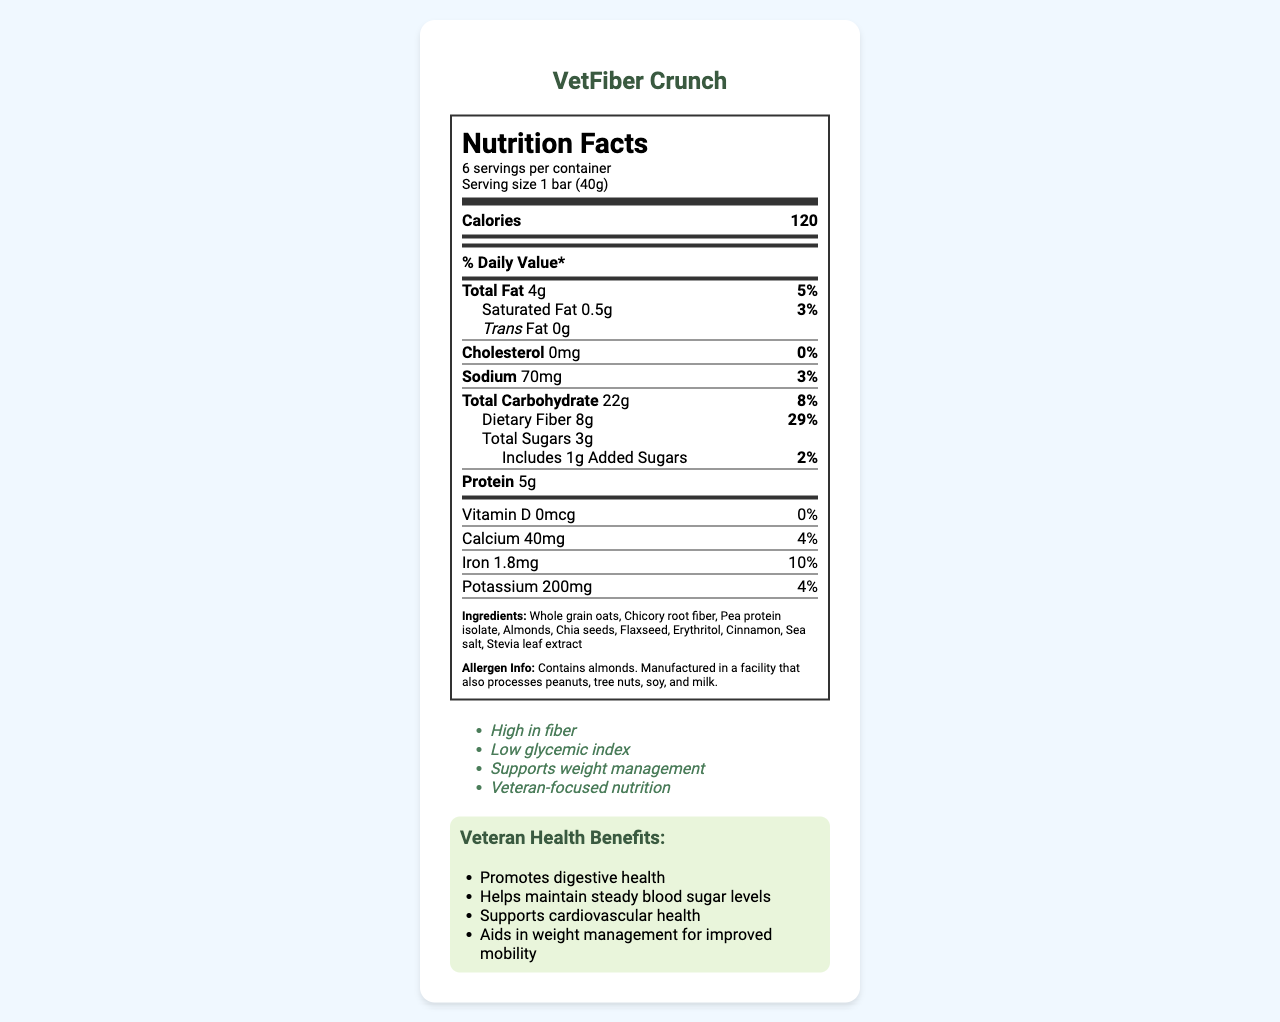what is the serving size? The document states that the serving size is 1 bar (40g).
Answer: 1 bar (40g) what are the total calories per serving? The document lists the calories per serving as 120.
Answer: 120 how much dietary fiber does one serving contain? The document shows that one serving contains 8g of dietary fiber.
Answer: 8g what is the % Daily Value of sodium per serving? The document indicates that the sodium content is 70mg, which is 3% of the daily value.
Answer: 3% what is the amount of protein per serving? The document lists the protein amount as 5g per serving.
Answer: 5g which ingredient is listed first in the ingredients list? The first ingredient listed in the document is whole grain oats.
Answer: Whole grain oats what is the cholesterol content in the product? The document shows that the cholesterol content is 0mg.
Answer: 0mg which of the following health claims is mentioned in the document? A. Supports bone health B. High in protein C. High in fiber D. Contains probiotics The document lists "High in fiber" as one of the health claims.
Answer: C how many servings are there in one container? A. 4 B. 6 C. 8 D. 10 The document states that there are 6 servings per container.
Answer: B is the product certified gluten-free? The document lists "Certified Gluten-Free" as one of the certifications.
Answer: Yes does the product contain any added sugars? The document shows that the product includes 1g of added sugars.
Answer: Yes what are the total carbohydrates per serving? The document lists the total carbohydrate content as 22g per serving.
Answer: 22g what is the main idea of this document? The document aims to inform readers about the nutritional content and health benefits of VetFiber Crunch, a specially formulated snack for veterans. It includes detailed information about serving size, calorie count, fats, fiber, sugars, proteins, vitamins, and minerals, as well as ingredient lists, allergen information, health claims, and certifications.
Answer: The document provides the nutrition facts, ingredients, health claims, veteran health benefits, and other relevant information of the high-fiber, diabetic-friendly snack called "VetFiber Crunch". It is designed for weight management in veteran populations. who is the manufacturer of the product? The document states that the product is manufactured by VetNutrition Solutions, Inc.
Answer: VetNutrition Solutions, Inc. how much added sugars are there per serving? The document lists the amount of added sugars as 1g per serving.
Answer: 1g what is the sodium content per serving in milligrams? The document shows that the sodium content per serving is 70mg.
Answer: 70mg does the product support cardiovascular health? The document lists "Supports cardiovascular health" as one of the veteran health benefits.
Answer: Yes can this product be determined as high in protein? The document does not provide enough information to categorize the product as high in protein, it only lists the protein content as 5g per serving.
Answer: Not enough information what should you do if you have questions or comments about the product? The document provides contact information for questions or comments: 1-800-VET-HEAL or www.vetfibercrunch.com.
Answer: Call 1-800-VET-HEAL or visit www.vetfibercrunch.com 